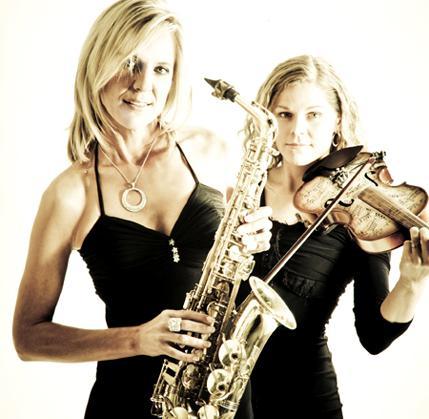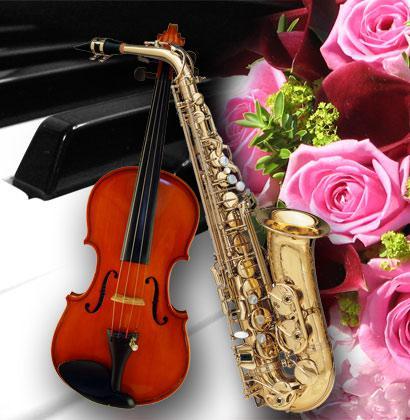The first image is the image on the left, the second image is the image on the right. Given the left and right images, does the statement "The lefthand image includes a woman in a cleavage-baring dress standing and holding a saxophone in front of a woman standing and playing violin." hold true? Answer yes or no. Yes. The first image is the image on the left, the second image is the image on the right. Examine the images to the left and right. Is the description "There are exactly two people in the left image." accurate? Answer yes or no. Yes. 